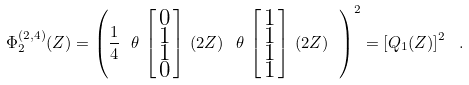Convert formula to latex. <formula><loc_0><loc_0><loc_500><loc_500>\Phi ^ { ( 2 , 4 ) } _ { 2 } ( Z ) = \left ( \frac { 1 } { 4 } \ \theta \, \left [ \begin{smallmatrix} 0 \\ 1 \\ 1 \\ 0 \end{smallmatrix} \right ] \, \left ( 2 Z \right ) \ \theta \, \left [ \begin{smallmatrix} 1 \\ 1 \\ 1 \\ 1 \end{smallmatrix} \right ] \, \left ( 2 Z \right ) \ \right ) ^ { 2 } = \left [ Q _ { 1 } ( Z ) \right ] ^ { 2 } \ .</formula> 